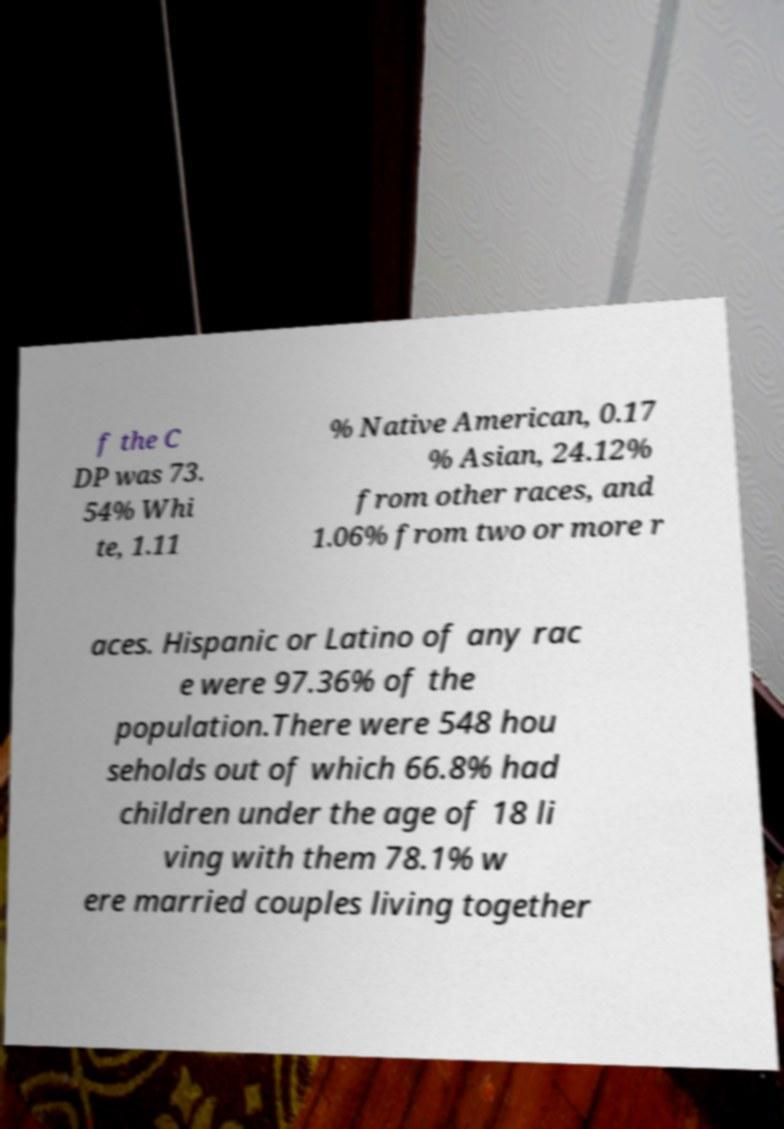There's text embedded in this image that I need extracted. Can you transcribe it verbatim? f the C DP was 73. 54% Whi te, 1.11 % Native American, 0.17 % Asian, 24.12% from other races, and 1.06% from two or more r aces. Hispanic or Latino of any rac e were 97.36% of the population.There were 548 hou seholds out of which 66.8% had children under the age of 18 li ving with them 78.1% w ere married couples living together 